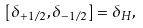Convert formula to latex. <formula><loc_0><loc_0><loc_500><loc_500>\left [ \delta _ { + 1 / 2 } , \delta _ { - 1 / 2 } \right ] = \delta _ { H } ,</formula> 